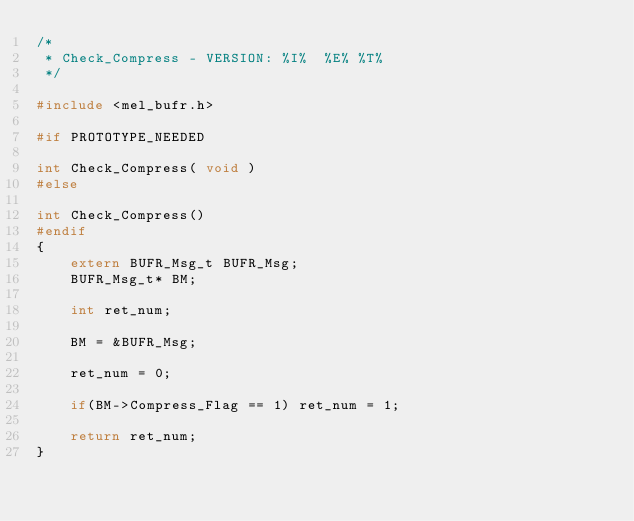Convert code to text. <code><loc_0><loc_0><loc_500><loc_500><_C_>/*
 * Check_Compress - VERSION: %I%  %E% %T%
 */

#include <mel_bufr.h>

#if PROTOTYPE_NEEDED

int Check_Compress( void )
#else

int Check_Compress()
#endif
{
    extern BUFR_Msg_t BUFR_Msg;
    BUFR_Msg_t* BM;

    int ret_num;

    BM = &BUFR_Msg;

    ret_num = 0;

    if(BM->Compress_Flag == 1) ret_num = 1;

    return ret_num;
}
</code> 